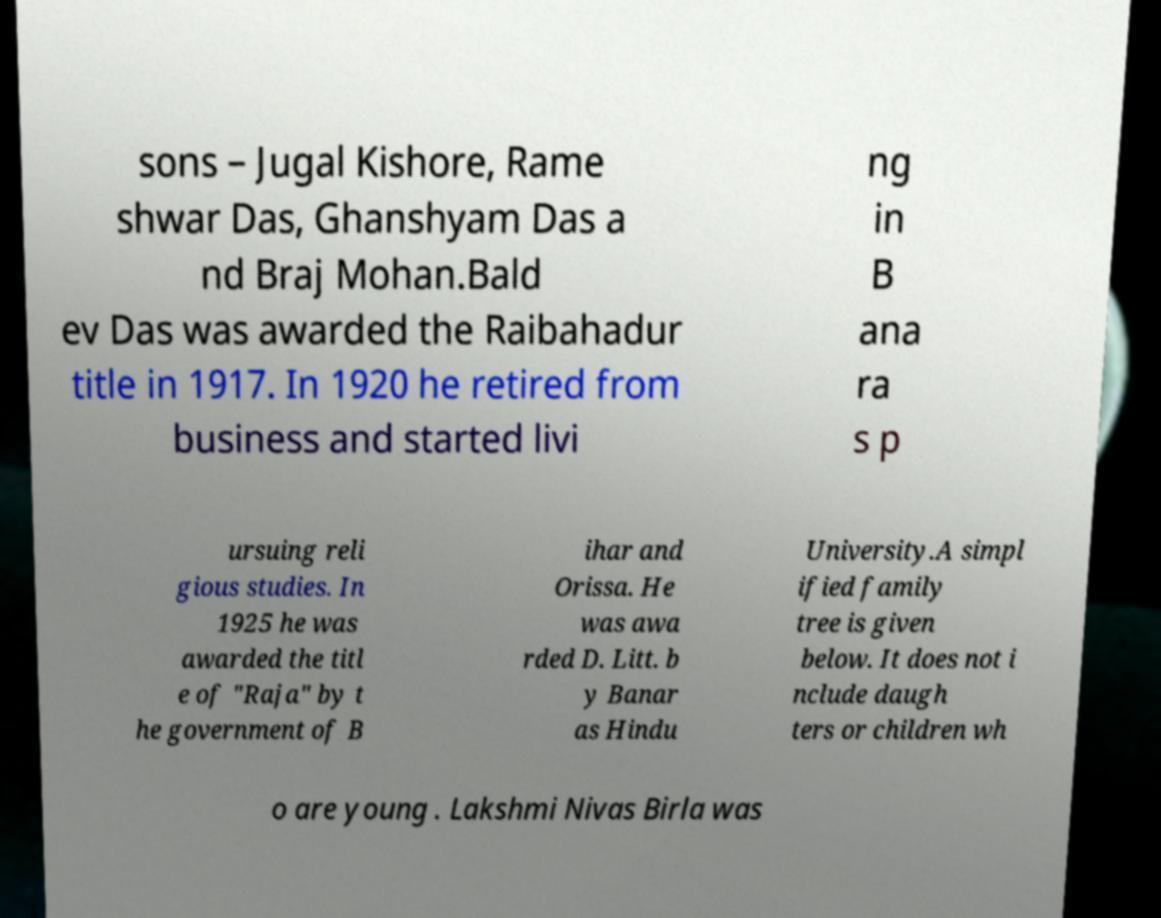Could you extract and type out the text from this image? sons – Jugal Kishore, Rame shwar Das, Ghanshyam Das a nd Braj Mohan.Bald ev Das was awarded the Raibahadur title in 1917. In 1920 he retired from business and started livi ng in B ana ra s p ursuing reli gious studies. In 1925 he was awarded the titl e of "Raja" by t he government of B ihar and Orissa. He was awa rded D. Litt. b y Banar as Hindu University.A simpl ified family tree is given below. It does not i nclude daugh ters or children wh o are young . Lakshmi Nivas Birla was 